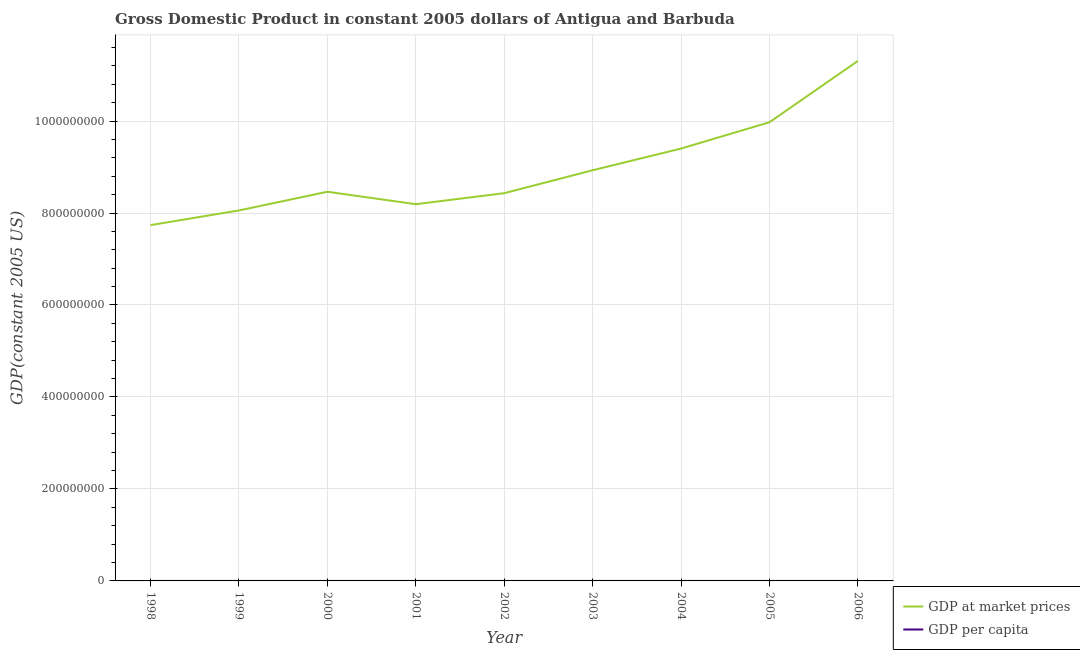Is the number of lines equal to the number of legend labels?
Your response must be concise. Yes. What is the gdp at market prices in 2003?
Offer a terse response. 8.93e+08. Across all years, what is the maximum gdp per capita?
Keep it short and to the point. 1.35e+04. Across all years, what is the minimum gdp at market prices?
Ensure brevity in your answer.  7.74e+08. What is the total gdp per capita in the graph?
Give a very brief answer. 1.01e+05. What is the difference between the gdp per capita in 1999 and that in 2000?
Your answer should be compact. -303.82. What is the difference between the gdp per capita in 1999 and the gdp at market prices in 2004?
Provide a short and direct response. -9.40e+08. What is the average gdp per capita per year?
Offer a terse response. 1.12e+04. In the year 2005, what is the difference between the gdp per capita and gdp at market prices?
Keep it short and to the point. -9.97e+08. What is the ratio of the gdp at market prices in 2001 to that in 2005?
Keep it short and to the point. 0.82. Is the difference between the gdp at market prices in 2000 and 2001 greater than the difference between the gdp per capita in 2000 and 2001?
Provide a succinct answer. Yes. What is the difference between the highest and the second highest gdp per capita?
Offer a terse response. 1467.85. What is the difference between the highest and the lowest gdp per capita?
Offer a very short reply. 3174.9. How many lines are there?
Provide a short and direct response. 2. How many years are there in the graph?
Your answer should be compact. 9. What is the difference between two consecutive major ticks on the Y-axis?
Keep it short and to the point. 2.00e+08. Are the values on the major ticks of Y-axis written in scientific E-notation?
Offer a terse response. No. Does the graph contain grids?
Offer a very short reply. Yes. How are the legend labels stacked?
Offer a terse response. Vertical. What is the title of the graph?
Provide a succinct answer. Gross Domestic Product in constant 2005 dollars of Antigua and Barbuda. What is the label or title of the X-axis?
Make the answer very short. Year. What is the label or title of the Y-axis?
Your answer should be compact. GDP(constant 2005 US). What is the GDP(constant 2005 US) in GDP at market prices in 1998?
Ensure brevity in your answer.  7.74e+08. What is the GDP(constant 2005 US) of GDP per capita in 1998?
Keep it short and to the point. 1.04e+04. What is the GDP(constant 2005 US) in GDP at market prices in 1999?
Keep it short and to the point. 8.06e+08. What is the GDP(constant 2005 US) of GDP per capita in 1999?
Offer a terse response. 1.06e+04. What is the GDP(constant 2005 US) of GDP at market prices in 2000?
Give a very brief answer. 8.46e+08. What is the GDP(constant 2005 US) in GDP per capita in 2000?
Offer a terse response. 1.09e+04. What is the GDP(constant 2005 US) of GDP at market prices in 2001?
Your answer should be very brief. 8.19e+08. What is the GDP(constant 2005 US) of GDP per capita in 2001?
Keep it short and to the point. 1.04e+04. What is the GDP(constant 2005 US) of GDP at market prices in 2002?
Your response must be concise. 8.43e+08. What is the GDP(constant 2005 US) in GDP per capita in 2002?
Offer a terse response. 1.05e+04. What is the GDP(constant 2005 US) of GDP at market prices in 2003?
Your answer should be compact. 8.93e+08. What is the GDP(constant 2005 US) in GDP per capita in 2003?
Offer a very short reply. 1.10e+04. What is the GDP(constant 2005 US) of GDP at market prices in 2004?
Make the answer very short. 9.40e+08. What is the GDP(constant 2005 US) in GDP per capita in 2004?
Provide a succinct answer. 1.15e+04. What is the GDP(constant 2005 US) of GDP at market prices in 2005?
Your answer should be compact. 9.97e+08. What is the GDP(constant 2005 US) in GDP per capita in 2005?
Ensure brevity in your answer.  1.21e+04. What is the GDP(constant 2005 US) in GDP at market prices in 2006?
Ensure brevity in your answer.  1.13e+09. What is the GDP(constant 2005 US) in GDP per capita in 2006?
Provide a short and direct response. 1.35e+04. Across all years, what is the maximum GDP(constant 2005 US) of GDP at market prices?
Provide a short and direct response. 1.13e+09. Across all years, what is the maximum GDP(constant 2005 US) of GDP per capita?
Make the answer very short. 1.35e+04. Across all years, what is the minimum GDP(constant 2005 US) of GDP at market prices?
Provide a succinct answer. 7.74e+08. Across all years, what is the minimum GDP(constant 2005 US) of GDP per capita?
Offer a terse response. 1.04e+04. What is the total GDP(constant 2005 US) in GDP at market prices in the graph?
Offer a terse response. 8.05e+09. What is the total GDP(constant 2005 US) of GDP per capita in the graph?
Provide a short and direct response. 1.01e+05. What is the difference between the GDP(constant 2005 US) in GDP at market prices in 1998 and that in 1999?
Offer a very short reply. -3.19e+07. What is the difference between the GDP(constant 2005 US) of GDP per capita in 1998 and that in 1999?
Offer a terse response. -167.75. What is the difference between the GDP(constant 2005 US) in GDP at market prices in 1998 and that in 2000?
Offer a terse response. -7.25e+07. What is the difference between the GDP(constant 2005 US) of GDP per capita in 1998 and that in 2000?
Keep it short and to the point. -471.57. What is the difference between the GDP(constant 2005 US) in GDP at market prices in 1998 and that in 2001?
Keep it short and to the point. -4.55e+07. What is the difference between the GDP(constant 2005 US) in GDP per capita in 1998 and that in 2001?
Your answer should be compact. 53.4. What is the difference between the GDP(constant 2005 US) in GDP at market prices in 1998 and that in 2002?
Offer a terse response. -6.94e+07. What is the difference between the GDP(constant 2005 US) in GDP per capita in 1998 and that in 2002?
Your response must be concise. -108.79. What is the difference between the GDP(constant 2005 US) in GDP at market prices in 1998 and that in 2003?
Ensure brevity in your answer.  -1.19e+08. What is the difference between the GDP(constant 2005 US) in GDP per capita in 1998 and that in 2003?
Keep it short and to the point. -611.25. What is the difference between the GDP(constant 2005 US) of GDP at market prices in 1998 and that in 2004?
Ensure brevity in your answer.  -1.66e+08. What is the difference between the GDP(constant 2005 US) of GDP per capita in 1998 and that in 2004?
Make the answer very short. -1078.98. What is the difference between the GDP(constant 2005 US) of GDP at market prices in 1998 and that in 2005?
Your answer should be compact. -2.24e+08. What is the difference between the GDP(constant 2005 US) in GDP per capita in 1998 and that in 2005?
Provide a short and direct response. -1653.66. What is the difference between the GDP(constant 2005 US) in GDP at market prices in 1998 and that in 2006?
Your response must be concise. -3.57e+08. What is the difference between the GDP(constant 2005 US) of GDP per capita in 1998 and that in 2006?
Provide a succinct answer. -3121.51. What is the difference between the GDP(constant 2005 US) in GDP at market prices in 1999 and that in 2000?
Give a very brief answer. -4.06e+07. What is the difference between the GDP(constant 2005 US) of GDP per capita in 1999 and that in 2000?
Ensure brevity in your answer.  -303.82. What is the difference between the GDP(constant 2005 US) in GDP at market prices in 1999 and that in 2001?
Your response must be concise. -1.36e+07. What is the difference between the GDP(constant 2005 US) in GDP per capita in 1999 and that in 2001?
Provide a succinct answer. 221.15. What is the difference between the GDP(constant 2005 US) in GDP at market prices in 1999 and that in 2002?
Your response must be concise. -3.75e+07. What is the difference between the GDP(constant 2005 US) of GDP per capita in 1999 and that in 2002?
Ensure brevity in your answer.  58.97. What is the difference between the GDP(constant 2005 US) in GDP at market prices in 1999 and that in 2003?
Give a very brief answer. -8.74e+07. What is the difference between the GDP(constant 2005 US) in GDP per capita in 1999 and that in 2003?
Provide a succinct answer. -443.5. What is the difference between the GDP(constant 2005 US) of GDP at market prices in 1999 and that in 2004?
Your answer should be very brief. -1.35e+08. What is the difference between the GDP(constant 2005 US) in GDP per capita in 1999 and that in 2004?
Make the answer very short. -911.22. What is the difference between the GDP(constant 2005 US) in GDP at market prices in 1999 and that in 2005?
Keep it short and to the point. -1.92e+08. What is the difference between the GDP(constant 2005 US) in GDP per capita in 1999 and that in 2005?
Offer a very short reply. -1485.9. What is the difference between the GDP(constant 2005 US) of GDP at market prices in 1999 and that in 2006?
Give a very brief answer. -3.25e+08. What is the difference between the GDP(constant 2005 US) in GDP per capita in 1999 and that in 2006?
Offer a very short reply. -2953.75. What is the difference between the GDP(constant 2005 US) of GDP at market prices in 2000 and that in 2001?
Provide a succinct answer. 2.70e+07. What is the difference between the GDP(constant 2005 US) of GDP per capita in 2000 and that in 2001?
Ensure brevity in your answer.  524.97. What is the difference between the GDP(constant 2005 US) in GDP at market prices in 2000 and that in 2002?
Your answer should be compact. 3.08e+06. What is the difference between the GDP(constant 2005 US) of GDP per capita in 2000 and that in 2002?
Your answer should be compact. 362.78. What is the difference between the GDP(constant 2005 US) of GDP at market prices in 2000 and that in 2003?
Offer a very short reply. -4.68e+07. What is the difference between the GDP(constant 2005 US) of GDP per capita in 2000 and that in 2003?
Offer a terse response. -139.68. What is the difference between the GDP(constant 2005 US) in GDP at market prices in 2000 and that in 2004?
Give a very brief answer. -9.40e+07. What is the difference between the GDP(constant 2005 US) of GDP per capita in 2000 and that in 2004?
Ensure brevity in your answer.  -607.41. What is the difference between the GDP(constant 2005 US) of GDP at market prices in 2000 and that in 2005?
Your answer should be compact. -1.51e+08. What is the difference between the GDP(constant 2005 US) of GDP per capita in 2000 and that in 2005?
Your answer should be compact. -1182.09. What is the difference between the GDP(constant 2005 US) in GDP at market prices in 2000 and that in 2006?
Offer a very short reply. -2.85e+08. What is the difference between the GDP(constant 2005 US) of GDP per capita in 2000 and that in 2006?
Ensure brevity in your answer.  -2649.93. What is the difference between the GDP(constant 2005 US) in GDP at market prices in 2001 and that in 2002?
Provide a short and direct response. -2.40e+07. What is the difference between the GDP(constant 2005 US) of GDP per capita in 2001 and that in 2002?
Ensure brevity in your answer.  -162.19. What is the difference between the GDP(constant 2005 US) of GDP at market prices in 2001 and that in 2003?
Offer a very short reply. -7.38e+07. What is the difference between the GDP(constant 2005 US) in GDP per capita in 2001 and that in 2003?
Your answer should be compact. -664.65. What is the difference between the GDP(constant 2005 US) of GDP at market prices in 2001 and that in 2004?
Offer a very short reply. -1.21e+08. What is the difference between the GDP(constant 2005 US) in GDP per capita in 2001 and that in 2004?
Ensure brevity in your answer.  -1132.38. What is the difference between the GDP(constant 2005 US) of GDP at market prices in 2001 and that in 2005?
Your response must be concise. -1.78e+08. What is the difference between the GDP(constant 2005 US) in GDP per capita in 2001 and that in 2005?
Keep it short and to the point. -1707.06. What is the difference between the GDP(constant 2005 US) of GDP at market prices in 2001 and that in 2006?
Ensure brevity in your answer.  -3.12e+08. What is the difference between the GDP(constant 2005 US) in GDP per capita in 2001 and that in 2006?
Your response must be concise. -3174.91. What is the difference between the GDP(constant 2005 US) in GDP at market prices in 2002 and that in 2003?
Offer a terse response. -4.99e+07. What is the difference between the GDP(constant 2005 US) in GDP per capita in 2002 and that in 2003?
Your response must be concise. -502.46. What is the difference between the GDP(constant 2005 US) in GDP at market prices in 2002 and that in 2004?
Give a very brief answer. -9.71e+07. What is the difference between the GDP(constant 2005 US) of GDP per capita in 2002 and that in 2004?
Ensure brevity in your answer.  -970.19. What is the difference between the GDP(constant 2005 US) in GDP at market prices in 2002 and that in 2005?
Your response must be concise. -1.54e+08. What is the difference between the GDP(constant 2005 US) of GDP per capita in 2002 and that in 2005?
Ensure brevity in your answer.  -1544.87. What is the difference between the GDP(constant 2005 US) of GDP at market prices in 2002 and that in 2006?
Offer a terse response. -2.88e+08. What is the difference between the GDP(constant 2005 US) of GDP per capita in 2002 and that in 2006?
Offer a very short reply. -3012.72. What is the difference between the GDP(constant 2005 US) in GDP at market prices in 2003 and that in 2004?
Your response must be concise. -4.72e+07. What is the difference between the GDP(constant 2005 US) of GDP per capita in 2003 and that in 2004?
Keep it short and to the point. -467.73. What is the difference between the GDP(constant 2005 US) of GDP at market prices in 2003 and that in 2005?
Keep it short and to the point. -1.04e+08. What is the difference between the GDP(constant 2005 US) of GDP per capita in 2003 and that in 2005?
Give a very brief answer. -1042.41. What is the difference between the GDP(constant 2005 US) of GDP at market prices in 2003 and that in 2006?
Give a very brief answer. -2.38e+08. What is the difference between the GDP(constant 2005 US) in GDP per capita in 2003 and that in 2006?
Provide a succinct answer. -2510.26. What is the difference between the GDP(constant 2005 US) of GDP at market prices in 2004 and that in 2005?
Your answer should be compact. -5.72e+07. What is the difference between the GDP(constant 2005 US) of GDP per capita in 2004 and that in 2005?
Offer a very short reply. -574.68. What is the difference between the GDP(constant 2005 US) of GDP at market prices in 2004 and that in 2006?
Your answer should be compact. -1.91e+08. What is the difference between the GDP(constant 2005 US) of GDP per capita in 2004 and that in 2006?
Offer a terse response. -2042.53. What is the difference between the GDP(constant 2005 US) in GDP at market prices in 2005 and that in 2006?
Your answer should be compact. -1.33e+08. What is the difference between the GDP(constant 2005 US) in GDP per capita in 2005 and that in 2006?
Make the answer very short. -1467.85. What is the difference between the GDP(constant 2005 US) in GDP at market prices in 1998 and the GDP(constant 2005 US) in GDP per capita in 1999?
Your answer should be compact. 7.74e+08. What is the difference between the GDP(constant 2005 US) of GDP at market prices in 1998 and the GDP(constant 2005 US) of GDP per capita in 2000?
Your response must be concise. 7.74e+08. What is the difference between the GDP(constant 2005 US) in GDP at market prices in 1998 and the GDP(constant 2005 US) in GDP per capita in 2001?
Make the answer very short. 7.74e+08. What is the difference between the GDP(constant 2005 US) of GDP at market prices in 1998 and the GDP(constant 2005 US) of GDP per capita in 2002?
Offer a very short reply. 7.74e+08. What is the difference between the GDP(constant 2005 US) in GDP at market prices in 1998 and the GDP(constant 2005 US) in GDP per capita in 2003?
Your response must be concise. 7.74e+08. What is the difference between the GDP(constant 2005 US) in GDP at market prices in 1998 and the GDP(constant 2005 US) in GDP per capita in 2004?
Your response must be concise. 7.74e+08. What is the difference between the GDP(constant 2005 US) in GDP at market prices in 1998 and the GDP(constant 2005 US) in GDP per capita in 2005?
Ensure brevity in your answer.  7.74e+08. What is the difference between the GDP(constant 2005 US) of GDP at market prices in 1998 and the GDP(constant 2005 US) of GDP per capita in 2006?
Your response must be concise. 7.74e+08. What is the difference between the GDP(constant 2005 US) of GDP at market prices in 1999 and the GDP(constant 2005 US) of GDP per capita in 2000?
Offer a terse response. 8.06e+08. What is the difference between the GDP(constant 2005 US) in GDP at market prices in 1999 and the GDP(constant 2005 US) in GDP per capita in 2001?
Ensure brevity in your answer.  8.06e+08. What is the difference between the GDP(constant 2005 US) of GDP at market prices in 1999 and the GDP(constant 2005 US) of GDP per capita in 2002?
Give a very brief answer. 8.06e+08. What is the difference between the GDP(constant 2005 US) in GDP at market prices in 1999 and the GDP(constant 2005 US) in GDP per capita in 2003?
Give a very brief answer. 8.06e+08. What is the difference between the GDP(constant 2005 US) in GDP at market prices in 1999 and the GDP(constant 2005 US) in GDP per capita in 2004?
Your answer should be compact. 8.06e+08. What is the difference between the GDP(constant 2005 US) in GDP at market prices in 1999 and the GDP(constant 2005 US) in GDP per capita in 2005?
Give a very brief answer. 8.06e+08. What is the difference between the GDP(constant 2005 US) of GDP at market prices in 1999 and the GDP(constant 2005 US) of GDP per capita in 2006?
Your response must be concise. 8.06e+08. What is the difference between the GDP(constant 2005 US) in GDP at market prices in 2000 and the GDP(constant 2005 US) in GDP per capita in 2001?
Ensure brevity in your answer.  8.46e+08. What is the difference between the GDP(constant 2005 US) in GDP at market prices in 2000 and the GDP(constant 2005 US) in GDP per capita in 2002?
Ensure brevity in your answer.  8.46e+08. What is the difference between the GDP(constant 2005 US) of GDP at market prices in 2000 and the GDP(constant 2005 US) of GDP per capita in 2003?
Your response must be concise. 8.46e+08. What is the difference between the GDP(constant 2005 US) of GDP at market prices in 2000 and the GDP(constant 2005 US) of GDP per capita in 2004?
Ensure brevity in your answer.  8.46e+08. What is the difference between the GDP(constant 2005 US) in GDP at market prices in 2000 and the GDP(constant 2005 US) in GDP per capita in 2005?
Provide a succinct answer. 8.46e+08. What is the difference between the GDP(constant 2005 US) in GDP at market prices in 2000 and the GDP(constant 2005 US) in GDP per capita in 2006?
Your answer should be very brief. 8.46e+08. What is the difference between the GDP(constant 2005 US) in GDP at market prices in 2001 and the GDP(constant 2005 US) in GDP per capita in 2002?
Offer a very short reply. 8.19e+08. What is the difference between the GDP(constant 2005 US) of GDP at market prices in 2001 and the GDP(constant 2005 US) of GDP per capita in 2003?
Give a very brief answer. 8.19e+08. What is the difference between the GDP(constant 2005 US) in GDP at market prices in 2001 and the GDP(constant 2005 US) in GDP per capita in 2004?
Your answer should be very brief. 8.19e+08. What is the difference between the GDP(constant 2005 US) in GDP at market prices in 2001 and the GDP(constant 2005 US) in GDP per capita in 2005?
Keep it short and to the point. 8.19e+08. What is the difference between the GDP(constant 2005 US) in GDP at market prices in 2001 and the GDP(constant 2005 US) in GDP per capita in 2006?
Your answer should be very brief. 8.19e+08. What is the difference between the GDP(constant 2005 US) of GDP at market prices in 2002 and the GDP(constant 2005 US) of GDP per capita in 2003?
Provide a short and direct response. 8.43e+08. What is the difference between the GDP(constant 2005 US) in GDP at market prices in 2002 and the GDP(constant 2005 US) in GDP per capita in 2004?
Your answer should be very brief. 8.43e+08. What is the difference between the GDP(constant 2005 US) in GDP at market prices in 2002 and the GDP(constant 2005 US) in GDP per capita in 2005?
Offer a very short reply. 8.43e+08. What is the difference between the GDP(constant 2005 US) in GDP at market prices in 2002 and the GDP(constant 2005 US) in GDP per capita in 2006?
Give a very brief answer. 8.43e+08. What is the difference between the GDP(constant 2005 US) of GDP at market prices in 2003 and the GDP(constant 2005 US) of GDP per capita in 2004?
Provide a succinct answer. 8.93e+08. What is the difference between the GDP(constant 2005 US) of GDP at market prices in 2003 and the GDP(constant 2005 US) of GDP per capita in 2005?
Your answer should be very brief. 8.93e+08. What is the difference between the GDP(constant 2005 US) of GDP at market prices in 2003 and the GDP(constant 2005 US) of GDP per capita in 2006?
Provide a succinct answer. 8.93e+08. What is the difference between the GDP(constant 2005 US) in GDP at market prices in 2004 and the GDP(constant 2005 US) in GDP per capita in 2005?
Make the answer very short. 9.40e+08. What is the difference between the GDP(constant 2005 US) in GDP at market prices in 2004 and the GDP(constant 2005 US) in GDP per capita in 2006?
Offer a terse response. 9.40e+08. What is the difference between the GDP(constant 2005 US) of GDP at market prices in 2005 and the GDP(constant 2005 US) of GDP per capita in 2006?
Ensure brevity in your answer.  9.97e+08. What is the average GDP(constant 2005 US) of GDP at market prices per year?
Offer a terse response. 8.94e+08. What is the average GDP(constant 2005 US) of GDP per capita per year?
Offer a terse response. 1.12e+04. In the year 1998, what is the difference between the GDP(constant 2005 US) in GDP at market prices and GDP(constant 2005 US) in GDP per capita?
Ensure brevity in your answer.  7.74e+08. In the year 1999, what is the difference between the GDP(constant 2005 US) in GDP at market prices and GDP(constant 2005 US) in GDP per capita?
Your answer should be compact. 8.06e+08. In the year 2000, what is the difference between the GDP(constant 2005 US) in GDP at market prices and GDP(constant 2005 US) in GDP per capita?
Your response must be concise. 8.46e+08. In the year 2001, what is the difference between the GDP(constant 2005 US) in GDP at market prices and GDP(constant 2005 US) in GDP per capita?
Make the answer very short. 8.19e+08. In the year 2002, what is the difference between the GDP(constant 2005 US) of GDP at market prices and GDP(constant 2005 US) of GDP per capita?
Keep it short and to the point. 8.43e+08. In the year 2003, what is the difference between the GDP(constant 2005 US) in GDP at market prices and GDP(constant 2005 US) in GDP per capita?
Provide a short and direct response. 8.93e+08. In the year 2004, what is the difference between the GDP(constant 2005 US) of GDP at market prices and GDP(constant 2005 US) of GDP per capita?
Keep it short and to the point. 9.40e+08. In the year 2005, what is the difference between the GDP(constant 2005 US) of GDP at market prices and GDP(constant 2005 US) of GDP per capita?
Offer a very short reply. 9.97e+08. In the year 2006, what is the difference between the GDP(constant 2005 US) in GDP at market prices and GDP(constant 2005 US) in GDP per capita?
Offer a terse response. 1.13e+09. What is the ratio of the GDP(constant 2005 US) of GDP at market prices in 1998 to that in 1999?
Offer a terse response. 0.96. What is the ratio of the GDP(constant 2005 US) in GDP per capita in 1998 to that in 1999?
Provide a succinct answer. 0.98. What is the ratio of the GDP(constant 2005 US) in GDP at market prices in 1998 to that in 2000?
Make the answer very short. 0.91. What is the ratio of the GDP(constant 2005 US) of GDP per capita in 1998 to that in 2000?
Offer a terse response. 0.96. What is the ratio of the GDP(constant 2005 US) in GDP at market prices in 1998 to that in 2001?
Ensure brevity in your answer.  0.94. What is the ratio of the GDP(constant 2005 US) of GDP at market prices in 1998 to that in 2002?
Your answer should be compact. 0.92. What is the ratio of the GDP(constant 2005 US) of GDP at market prices in 1998 to that in 2003?
Your response must be concise. 0.87. What is the ratio of the GDP(constant 2005 US) in GDP per capita in 1998 to that in 2003?
Your answer should be very brief. 0.94. What is the ratio of the GDP(constant 2005 US) of GDP at market prices in 1998 to that in 2004?
Make the answer very short. 0.82. What is the ratio of the GDP(constant 2005 US) of GDP per capita in 1998 to that in 2004?
Your answer should be very brief. 0.91. What is the ratio of the GDP(constant 2005 US) in GDP at market prices in 1998 to that in 2005?
Your answer should be very brief. 0.78. What is the ratio of the GDP(constant 2005 US) in GDP per capita in 1998 to that in 2005?
Offer a terse response. 0.86. What is the ratio of the GDP(constant 2005 US) of GDP at market prices in 1998 to that in 2006?
Your response must be concise. 0.68. What is the ratio of the GDP(constant 2005 US) of GDP per capita in 1998 to that in 2006?
Offer a terse response. 0.77. What is the ratio of the GDP(constant 2005 US) in GDP per capita in 1999 to that in 2000?
Offer a very short reply. 0.97. What is the ratio of the GDP(constant 2005 US) of GDP at market prices in 1999 to that in 2001?
Your answer should be compact. 0.98. What is the ratio of the GDP(constant 2005 US) in GDP per capita in 1999 to that in 2001?
Ensure brevity in your answer.  1.02. What is the ratio of the GDP(constant 2005 US) of GDP at market prices in 1999 to that in 2002?
Your answer should be compact. 0.96. What is the ratio of the GDP(constant 2005 US) of GDP per capita in 1999 to that in 2002?
Offer a terse response. 1.01. What is the ratio of the GDP(constant 2005 US) in GDP at market prices in 1999 to that in 2003?
Your answer should be compact. 0.9. What is the ratio of the GDP(constant 2005 US) in GDP per capita in 1999 to that in 2003?
Offer a very short reply. 0.96. What is the ratio of the GDP(constant 2005 US) in GDP at market prices in 1999 to that in 2004?
Offer a terse response. 0.86. What is the ratio of the GDP(constant 2005 US) of GDP per capita in 1999 to that in 2004?
Keep it short and to the point. 0.92. What is the ratio of the GDP(constant 2005 US) of GDP at market prices in 1999 to that in 2005?
Make the answer very short. 0.81. What is the ratio of the GDP(constant 2005 US) of GDP per capita in 1999 to that in 2005?
Keep it short and to the point. 0.88. What is the ratio of the GDP(constant 2005 US) of GDP at market prices in 1999 to that in 2006?
Ensure brevity in your answer.  0.71. What is the ratio of the GDP(constant 2005 US) in GDP per capita in 1999 to that in 2006?
Your response must be concise. 0.78. What is the ratio of the GDP(constant 2005 US) of GDP at market prices in 2000 to that in 2001?
Ensure brevity in your answer.  1.03. What is the ratio of the GDP(constant 2005 US) of GDP per capita in 2000 to that in 2001?
Offer a terse response. 1.05. What is the ratio of the GDP(constant 2005 US) of GDP per capita in 2000 to that in 2002?
Keep it short and to the point. 1.03. What is the ratio of the GDP(constant 2005 US) in GDP at market prices in 2000 to that in 2003?
Make the answer very short. 0.95. What is the ratio of the GDP(constant 2005 US) of GDP per capita in 2000 to that in 2003?
Ensure brevity in your answer.  0.99. What is the ratio of the GDP(constant 2005 US) of GDP per capita in 2000 to that in 2004?
Your answer should be very brief. 0.95. What is the ratio of the GDP(constant 2005 US) in GDP at market prices in 2000 to that in 2005?
Offer a very short reply. 0.85. What is the ratio of the GDP(constant 2005 US) in GDP per capita in 2000 to that in 2005?
Keep it short and to the point. 0.9. What is the ratio of the GDP(constant 2005 US) in GDP at market prices in 2000 to that in 2006?
Keep it short and to the point. 0.75. What is the ratio of the GDP(constant 2005 US) of GDP per capita in 2000 to that in 2006?
Keep it short and to the point. 0.8. What is the ratio of the GDP(constant 2005 US) in GDP at market prices in 2001 to that in 2002?
Make the answer very short. 0.97. What is the ratio of the GDP(constant 2005 US) in GDP per capita in 2001 to that in 2002?
Ensure brevity in your answer.  0.98. What is the ratio of the GDP(constant 2005 US) of GDP at market prices in 2001 to that in 2003?
Your response must be concise. 0.92. What is the ratio of the GDP(constant 2005 US) of GDP per capita in 2001 to that in 2003?
Offer a very short reply. 0.94. What is the ratio of the GDP(constant 2005 US) of GDP at market prices in 2001 to that in 2004?
Provide a succinct answer. 0.87. What is the ratio of the GDP(constant 2005 US) in GDP per capita in 2001 to that in 2004?
Your answer should be very brief. 0.9. What is the ratio of the GDP(constant 2005 US) of GDP at market prices in 2001 to that in 2005?
Your response must be concise. 0.82. What is the ratio of the GDP(constant 2005 US) of GDP per capita in 2001 to that in 2005?
Your response must be concise. 0.86. What is the ratio of the GDP(constant 2005 US) in GDP at market prices in 2001 to that in 2006?
Ensure brevity in your answer.  0.72. What is the ratio of the GDP(constant 2005 US) in GDP per capita in 2001 to that in 2006?
Your answer should be compact. 0.77. What is the ratio of the GDP(constant 2005 US) in GDP at market prices in 2002 to that in 2003?
Provide a succinct answer. 0.94. What is the ratio of the GDP(constant 2005 US) in GDP per capita in 2002 to that in 2003?
Offer a terse response. 0.95. What is the ratio of the GDP(constant 2005 US) of GDP at market prices in 2002 to that in 2004?
Provide a succinct answer. 0.9. What is the ratio of the GDP(constant 2005 US) in GDP per capita in 2002 to that in 2004?
Keep it short and to the point. 0.92. What is the ratio of the GDP(constant 2005 US) in GDP at market prices in 2002 to that in 2005?
Provide a succinct answer. 0.85. What is the ratio of the GDP(constant 2005 US) in GDP per capita in 2002 to that in 2005?
Your response must be concise. 0.87. What is the ratio of the GDP(constant 2005 US) in GDP at market prices in 2002 to that in 2006?
Make the answer very short. 0.75. What is the ratio of the GDP(constant 2005 US) in GDP per capita in 2002 to that in 2006?
Give a very brief answer. 0.78. What is the ratio of the GDP(constant 2005 US) in GDP at market prices in 2003 to that in 2004?
Provide a succinct answer. 0.95. What is the ratio of the GDP(constant 2005 US) in GDP per capita in 2003 to that in 2004?
Ensure brevity in your answer.  0.96. What is the ratio of the GDP(constant 2005 US) of GDP at market prices in 2003 to that in 2005?
Keep it short and to the point. 0.9. What is the ratio of the GDP(constant 2005 US) in GDP per capita in 2003 to that in 2005?
Offer a very short reply. 0.91. What is the ratio of the GDP(constant 2005 US) in GDP at market prices in 2003 to that in 2006?
Your answer should be compact. 0.79. What is the ratio of the GDP(constant 2005 US) of GDP per capita in 2003 to that in 2006?
Make the answer very short. 0.81. What is the ratio of the GDP(constant 2005 US) of GDP at market prices in 2004 to that in 2005?
Provide a succinct answer. 0.94. What is the ratio of the GDP(constant 2005 US) of GDP at market prices in 2004 to that in 2006?
Make the answer very short. 0.83. What is the ratio of the GDP(constant 2005 US) of GDP per capita in 2004 to that in 2006?
Ensure brevity in your answer.  0.85. What is the ratio of the GDP(constant 2005 US) in GDP at market prices in 2005 to that in 2006?
Give a very brief answer. 0.88. What is the ratio of the GDP(constant 2005 US) of GDP per capita in 2005 to that in 2006?
Provide a succinct answer. 0.89. What is the difference between the highest and the second highest GDP(constant 2005 US) of GDP at market prices?
Provide a succinct answer. 1.33e+08. What is the difference between the highest and the second highest GDP(constant 2005 US) of GDP per capita?
Provide a short and direct response. 1467.85. What is the difference between the highest and the lowest GDP(constant 2005 US) of GDP at market prices?
Offer a terse response. 3.57e+08. What is the difference between the highest and the lowest GDP(constant 2005 US) in GDP per capita?
Your answer should be very brief. 3174.91. 